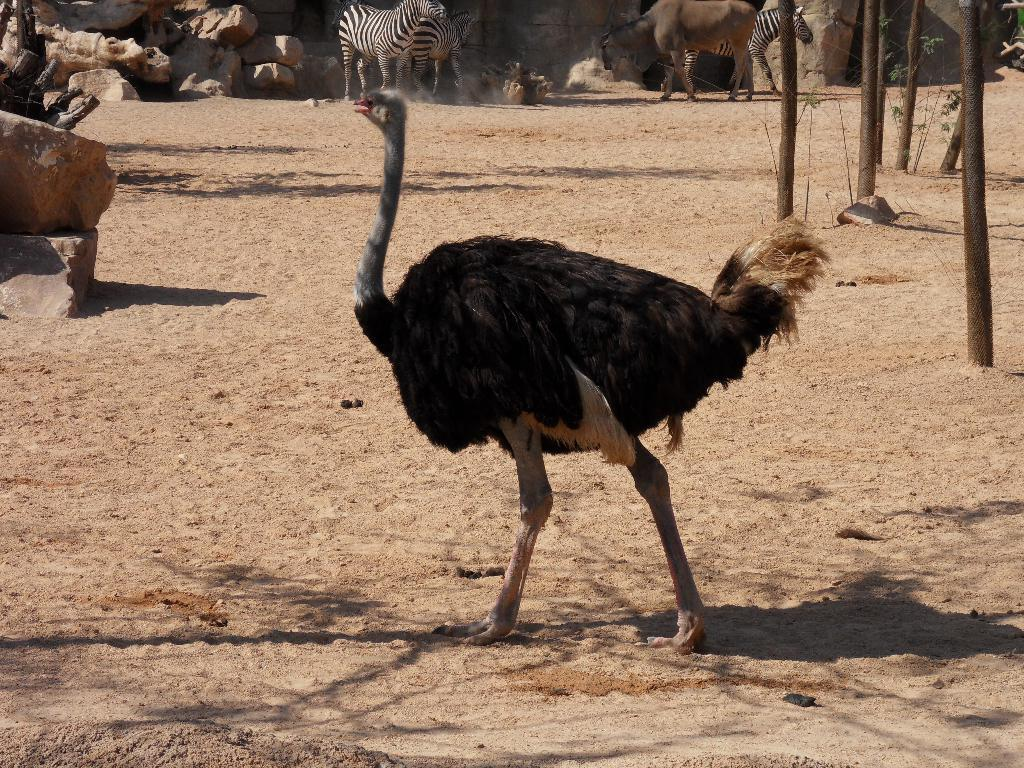What type of animal is on the ground in the image? There is an ostrich on the ground in the image. What type of natural elements can be seen in the image? Stones and plants are visible in the image. What type of man-made structures are present in the image? Wooden poles are present in the image. Are there any other animals in the image besides the ostrich? Yes, there is a group of animals in the image. What type of invention can be seen in the image? There is no invention present in the image. Are there any boats visible in the image? There are no boats present in the image. 